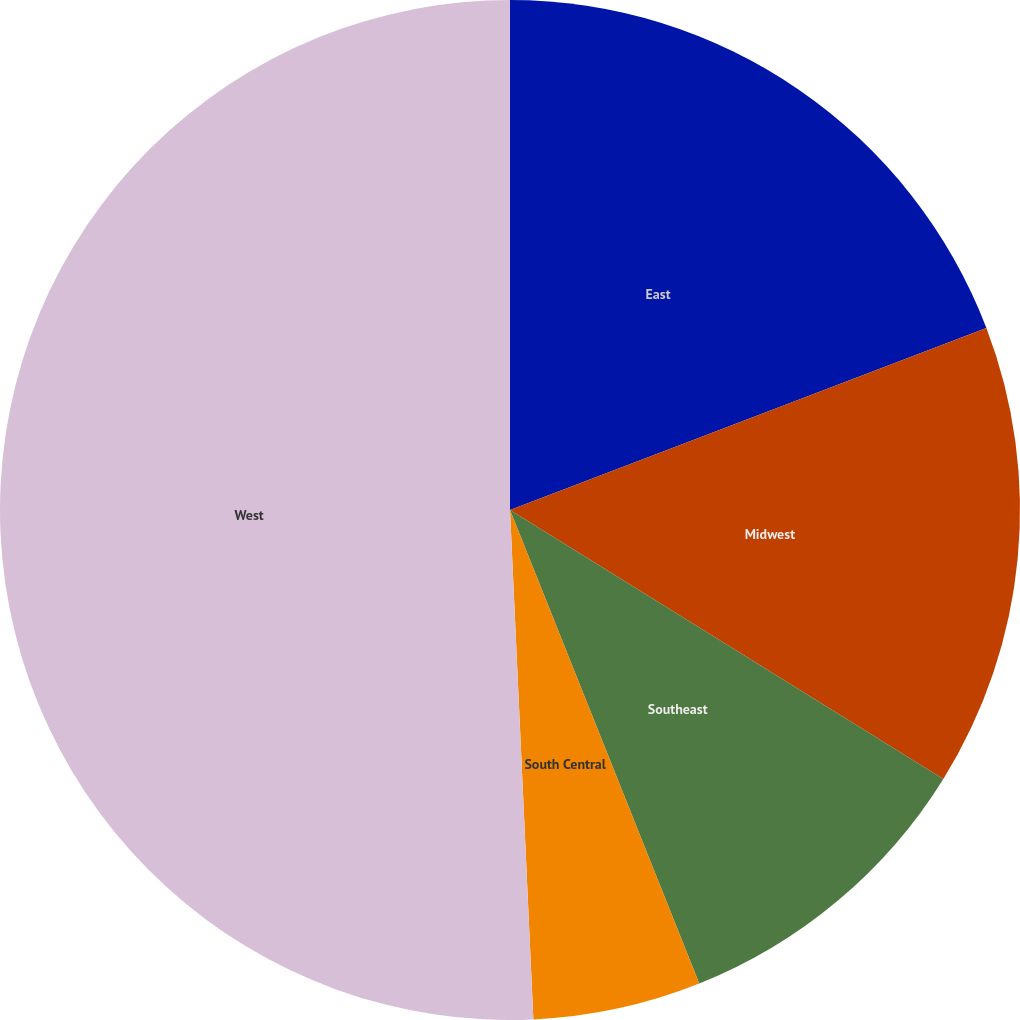<chart> <loc_0><loc_0><loc_500><loc_500><pie_chart><fcel>East<fcel>Midwest<fcel>Southeast<fcel>South Central<fcel>West<nl><fcel>19.19%<fcel>14.65%<fcel>10.11%<fcel>5.32%<fcel>50.73%<nl></chart> 